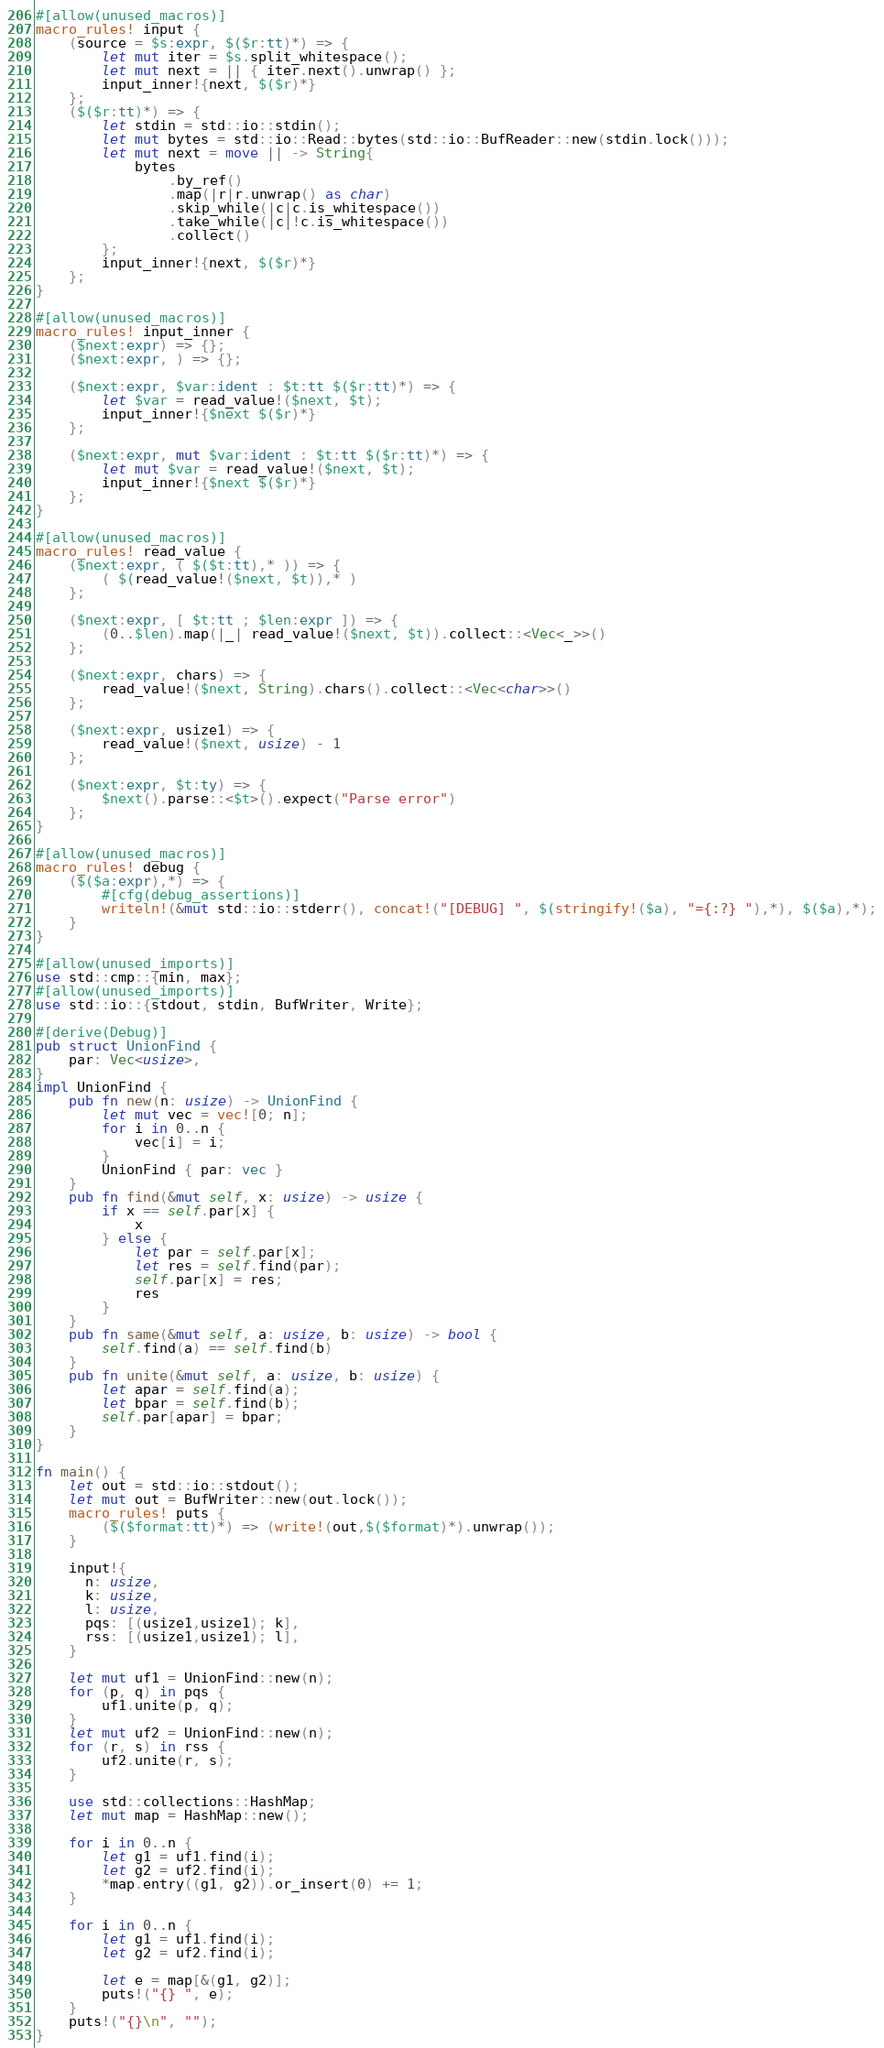Convert code to text. <code><loc_0><loc_0><loc_500><loc_500><_Rust_>#[allow(unused_macros)]
macro_rules! input {
    (source = $s:expr, $($r:tt)*) => {
        let mut iter = $s.split_whitespace();
        let mut next = || { iter.next().unwrap() };
        input_inner!{next, $($r)*}
    };
    ($($r:tt)*) => {
        let stdin = std::io::stdin();
        let mut bytes = std::io::Read::bytes(std::io::BufReader::new(stdin.lock()));
        let mut next = move || -> String{
            bytes
                .by_ref()
                .map(|r|r.unwrap() as char)
                .skip_while(|c|c.is_whitespace())
                .take_while(|c|!c.is_whitespace())
                .collect()
        };
        input_inner!{next, $($r)*}
    };
}

#[allow(unused_macros)]
macro_rules! input_inner {
    ($next:expr) => {};
    ($next:expr, ) => {};

    ($next:expr, $var:ident : $t:tt $($r:tt)*) => {
        let $var = read_value!($next, $t);
        input_inner!{$next $($r)*}
    };

    ($next:expr, mut $var:ident : $t:tt $($r:tt)*) => {
        let mut $var = read_value!($next, $t);
        input_inner!{$next $($r)*}
    };
}

#[allow(unused_macros)]
macro_rules! read_value {
    ($next:expr, ( $($t:tt),* )) => {
        ( $(read_value!($next, $t)),* )
    };

    ($next:expr, [ $t:tt ; $len:expr ]) => {
        (0..$len).map(|_| read_value!($next, $t)).collect::<Vec<_>>()
    };

    ($next:expr, chars) => {
        read_value!($next, String).chars().collect::<Vec<char>>()
    };

    ($next:expr, usize1) => {
        read_value!($next, usize) - 1
    };

    ($next:expr, $t:ty) => {
        $next().parse::<$t>().expect("Parse error")
    };
}

#[allow(unused_macros)]
macro_rules! debug {
    ($($a:expr),*) => {
        #[cfg(debug_assertions)]
        writeln!(&mut std::io::stderr(), concat!("[DEBUG] ", $(stringify!($a), "={:?} "),*), $($a),*);
    }
}

#[allow(unused_imports)]
use std::cmp::{min, max};
#[allow(unused_imports)]
use std::io::{stdout, stdin, BufWriter, Write};

#[derive(Debug)]
pub struct UnionFind {
    par: Vec<usize>,
}
impl UnionFind {
    pub fn new(n: usize) -> UnionFind {
        let mut vec = vec![0; n];
        for i in 0..n {
            vec[i] = i;
        }
        UnionFind { par: vec }
    }
    pub fn find(&mut self, x: usize) -> usize {
        if x == self.par[x] {
            x
        } else {
            let par = self.par[x];
            let res = self.find(par);
            self.par[x] = res;
            res
        }
    }
    pub fn same(&mut self, a: usize, b: usize) -> bool {
        self.find(a) == self.find(b)
    }
    pub fn unite(&mut self, a: usize, b: usize) {
        let apar = self.find(a);
        let bpar = self.find(b);
        self.par[apar] = bpar;
    }
}

fn main() {
    let out = std::io::stdout();
    let mut out = BufWriter::new(out.lock());
    macro_rules! puts {
        ($($format:tt)*) => (write!(out,$($format)*).unwrap());
    }

    input!{
      n: usize,
      k: usize,
      l: usize,
      pqs: [(usize1,usize1); k],
      rss: [(usize1,usize1); l],
    }

    let mut uf1 = UnionFind::new(n);
    for (p, q) in pqs {
        uf1.unite(p, q);
    }
    let mut uf2 = UnionFind::new(n);
    for (r, s) in rss {
        uf2.unite(r, s);
    }

    use std::collections::HashMap;
    let mut map = HashMap::new();

    for i in 0..n {
        let g1 = uf1.find(i);
        let g2 = uf2.find(i);
        *map.entry((g1, g2)).or_insert(0) += 1;
    }

    for i in 0..n {
        let g1 = uf1.find(i);
        let g2 = uf2.find(i);

        let e = map[&(g1, g2)];
        puts!("{} ", e);
    }
    puts!("{}\n", "");
}
</code> 